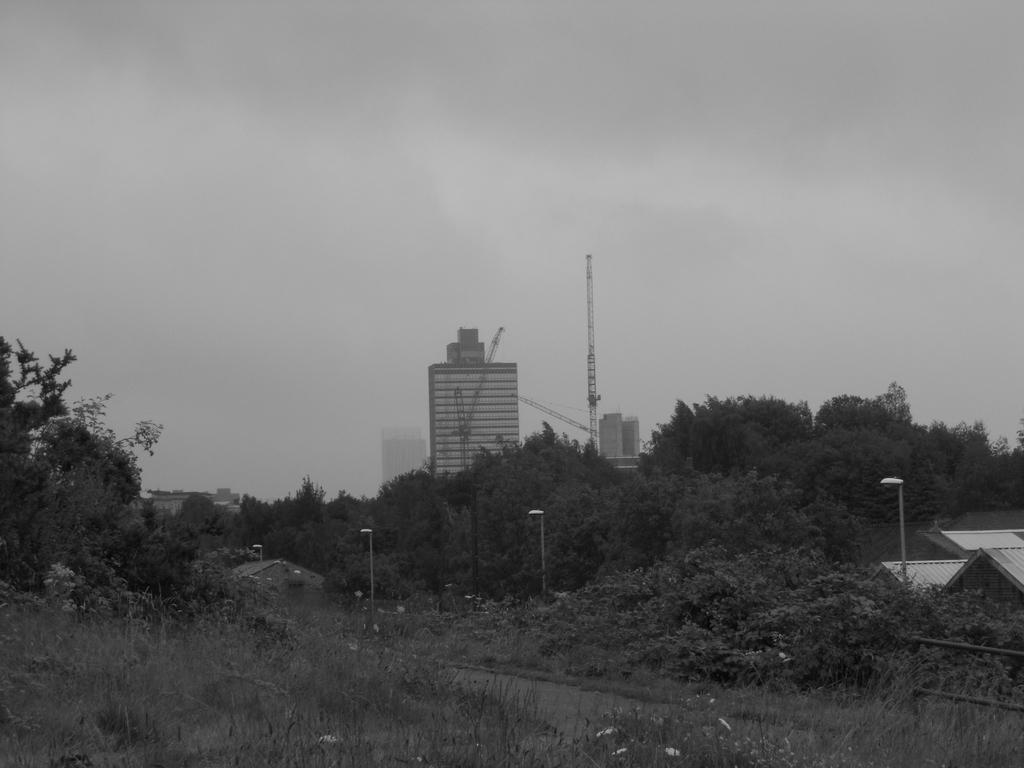What type of vegetation is present in the image? There is grass, bushes, and trees in the image. What type of structures can be seen in the image? There are lamp posts and buildings in the image. What type of soda is being served at the flight depicted in the image? There is no flight or soda present in the image; it features grass, bushes, trees, lamp posts, and buildings. 